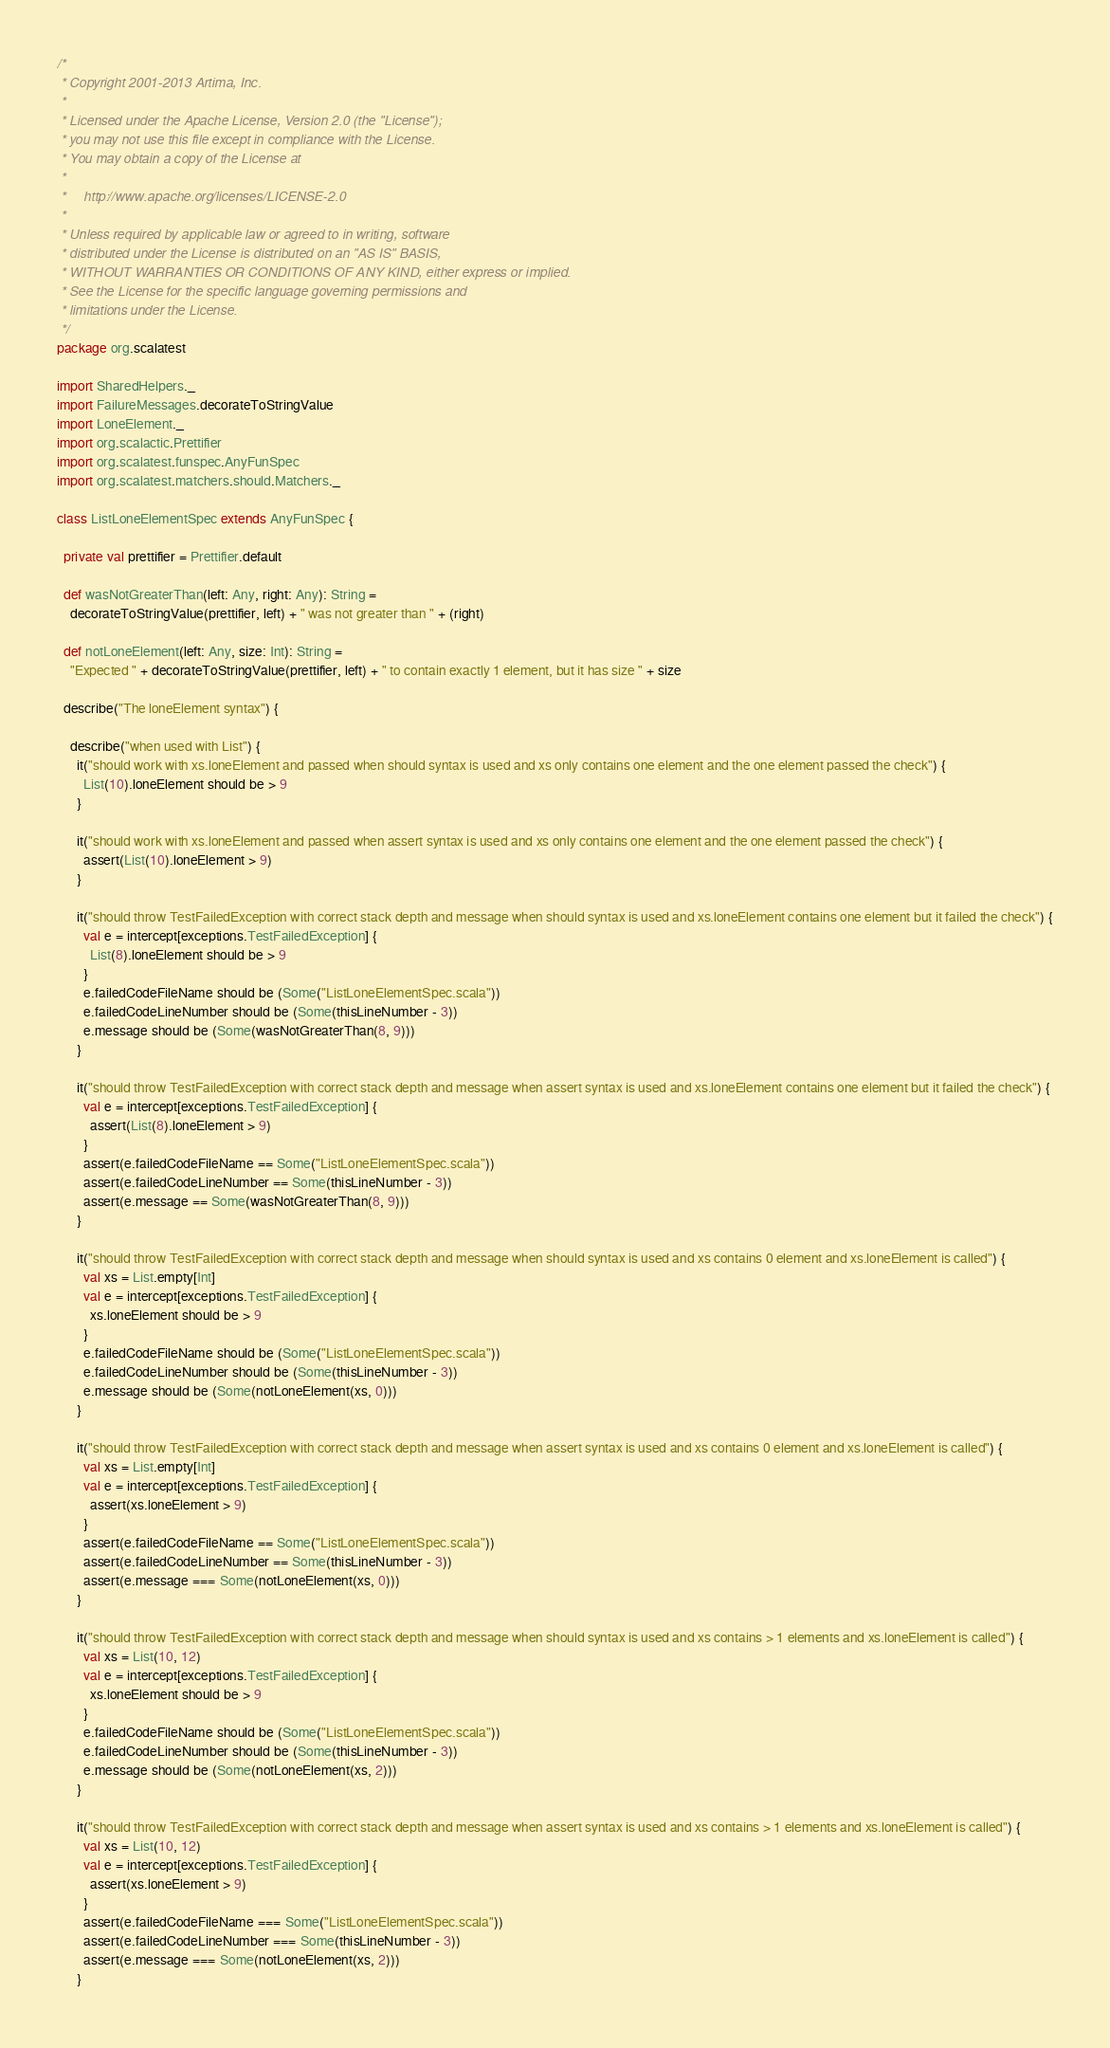<code> <loc_0><loc_0><loc_500><loc_500><_Scala_>/*
 * Copyright 2001-2013 Artima, Inc.
 *
 * Licensed under the Apache License, Version 2.0 (the "License");
 * you may not use this file except in compliance with the License.
 * You may obtain a copy of the License at
 *
 *     http://www.apache.org/licenses/LICENSE-2.0
 *
 * Unless required by applicable law or agreed to in writing, software
 * distributed under the License is distributed on an "AS IS" BASIS,
 * WITHOUT WARRANTIES OR CONDITIONS OF ANY KIND, either express or implied.
 * See the License for the specific language governing permissions and
 * limitations under the License.
 */
package org.scalatest

import SharedHelpers._
import FailureMessages.decorateToStringValue
import LoneElement._
import org.scalactic.Prettifier
import org.scalatest.funspec.AnyFunSpec
import org.scalatest.matchers.should.Matchers._

class ListLoneElementSpec extends AnyFunSpec {

  private val prettifier = Prettifier.default
  
  def wasNotGreaterThan(left: Any, right: Any): String = 
    decorateToStringValue(prettifier, left) + " was not greater than " + (right)
    
  def notLoneElement(left: Any, size: Int): String = 
    "Expected " + decorateToStringValue(prettifier, left) + " to contain exactly 1 element, but it has size " + size

  describe("The loneElement syntax") {
    
    describe("when used with List") {
      it("should work with xs.loneElement and passed when should syntax is used and xs only contains one element and the one element passed the check") {
        List(10).loneElement should be > 9
      }
      
      it("should work with xs.loneElement and passed when assert syntax is used and xs only contains one element and the one element passed the check") {
        assert(List(10).loneElement > 9)
      }
      
      it("should throw TestFailedException with correct stack depth and message when should syntax is used and xs.loneElement contains one element but it failed the check") {
        val e = intercept[exceptions.TestFailedException] {
          List(8).loneElement should be > 9
        }
        e.failedCodeFileName should be (Some("ListLoneElementSpec.scala"))
        e.failedCodeLineNumber should be (Some(thisLineNumber - 3))
        e.message should be (Some(wasNotGreaterThan(8, 9)))
      }
      
      it("should throw TestFailedException with correct stack depth and message when assert syntax is used and xs.loneElement contains one element but it failed the check") {
        val e = intercept[exceptions.TestFailedException] {
          assert(List(8).loneElement > 9)
        }
        assert(e.failedCodeFileName == Some("ListLoneElementSpec.scala"))
        assert(e.failedCodeLineNumber == Some(thisLineNumber - 3))
        assert(e.message == Some(wasNotGreaterThan(8, 9)))
      }
      
      it("should throw TestFailedException with correct stack depth and message when should syntax is used and xs contains 0 element and xs.loneElement is called") {
        val xs = List.empty[Int]
        val e = intercept[exceptions.TestFailedException] {
          xs.loneElement should be > 9
        }
        e.failedCodeFileName should be (Some("ListLoneElementSpec.scala"))
        e.failedCodeLineNumber should be (Some(thisLineNumber - 3))
        e.message should be (Some(notLoneElement(xs, 0)))
      }
      
      it("should throw TestFailedException with correct stack depth and message when assert syntax is used and xs contains 0 element and xs.loneElement is called") {
        val xs = List.empty[Int]
        val e = intercept[exceptions.TestFailedException] {
          assert(xs.loneElement > 9)
        }
        assert(e.failedCodeFileName == Some("ListLoneElementSpec.scala"))
        assert(e.failedCodeLineNumber == Some(thisLineNumber - 3))
        assert(e.message === Some(notLoneElement(xs, 0)))
      }
      
      it("should throw TestFailedException with correct stack depth and message when should syntax is used and xs contains > 1 elements and xs.loneElement is called") {
        val xs = List(10, 12)
        val e = intercept[exceptions.TestFailedException] {
          xs.loneElement should be > 9
        }
        e.failedCodeFileName should be (Some("ListLoneElementSpec.scala"))
        e.failedCodeLineNumber should be (Some(thisLineNumber - 3))
        e.message should be (Some(notLoneElement(xs, 2)))
      }
      
      it("should throw TestFailedException with correct stack depth and message when assert syntax is used and xs contains > 1 elements and xs.loneElement is called") {
        val xs = List(10, 12)
        val e = intercept[exceptions.TestFailedException] {
          assert(xs.loneElement > 9)
        }
        assert(e.failedCodeFileName === Some("ListLoneElementSpec.scala"))
        assert(e.failedCodeLineNumber === Some(thisLineNumber - 3))
        assert(e.message === Some(notLoneElement(xs, 2)))
      }</code> 